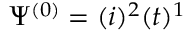Convert formula to latex. <formula><loc_0><loc_0><loc_500><loc_500>\Psi ^ { ( 0 ) } = { ( i ) ^ { 2 } ( t ) ^ { 1 } }</formula> 